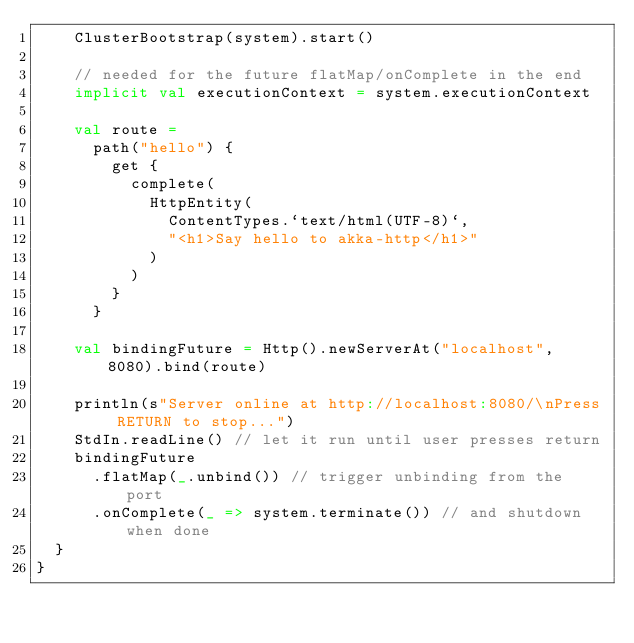Convert code to text. <code><loc_0><loc_0><loc_500><loc_500><_Scala_>    ClusterBootstrap(system).start()

    // needed for the future flatMap/onComplete in the end
    implicit val executionContext = system.executionContext

    val route =
      path("hello") {
        get {
          complete(
            HttpEntity(
              ContentTypes.`text/html(UTF-8)`,
              "<h1>Say hello to akka-http</h1>"
            )
          )
        }
      }

    val bindingFuture = Http().newServerAt("localhost", 8080).bind(route)

    println(s"Server online at http://localhost:8080/\nPress RETURN to stop...")
    StdIn.readLine() // let it run until user presses return
    bindingFuture
      .flatMap(_.unbind()) // trigger unbinding from the port
      .onComplete(_ => system.terminate()) // and shutdown when done
  }
}
</code> 